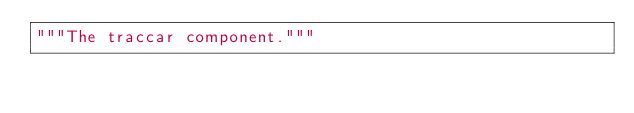<code> <loc_0><loc_0><loc_500><loc_500><_Python_>"""The traccar component."""
</code> 